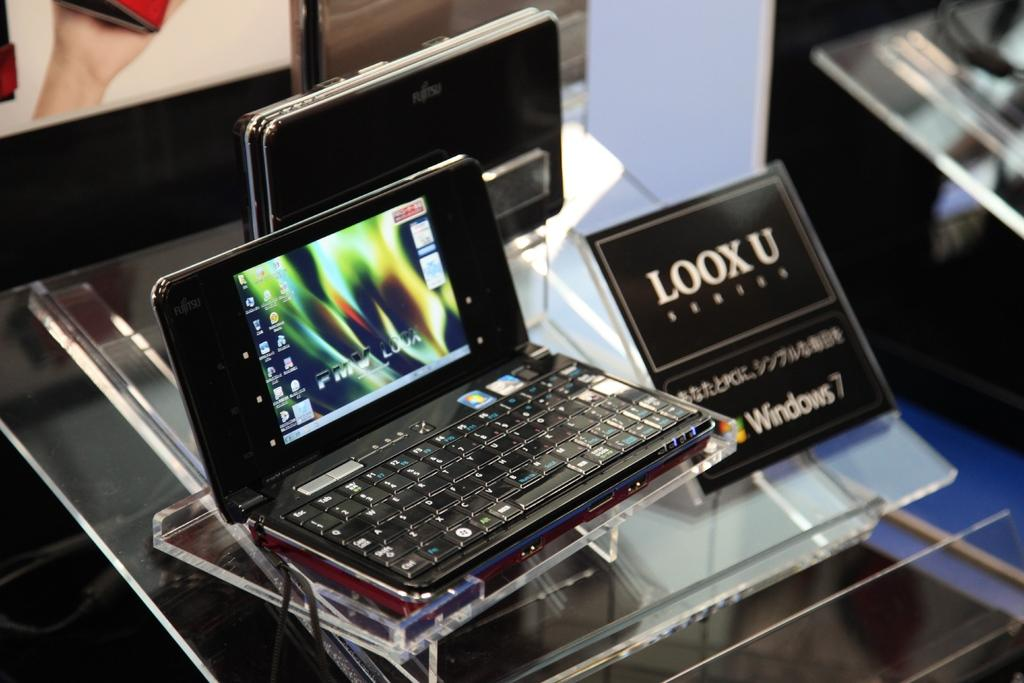<image>
Share a concise interpretation of the image provided. A small black laptop with a black sing next to it that says Loox U. 